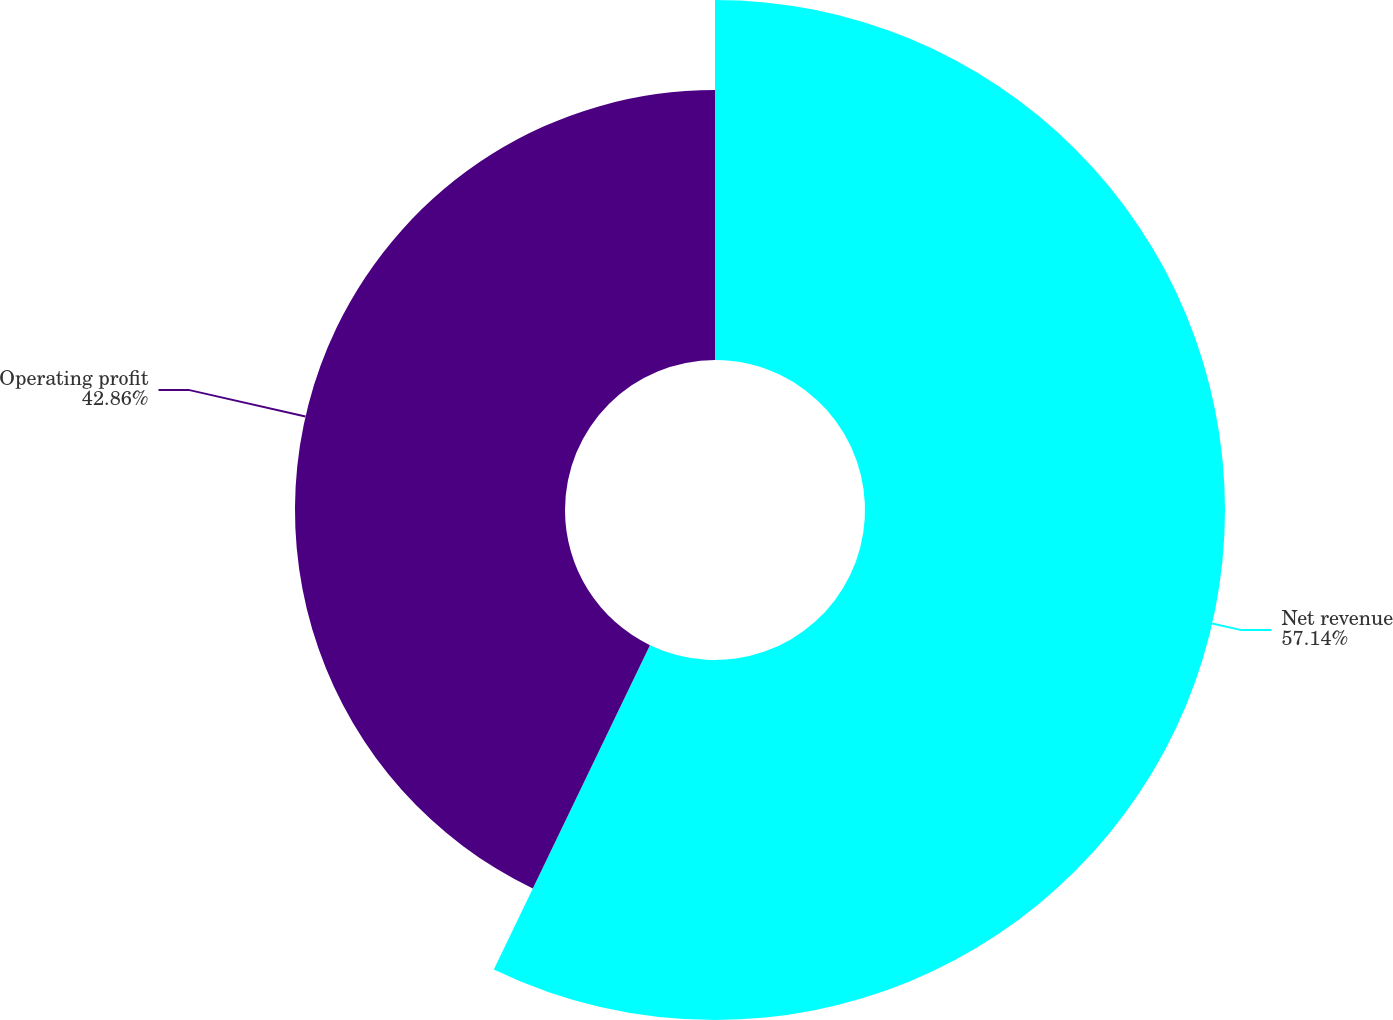<chart> <loc_0><loc_0><loc_500><loc_500><pie_chart><fcel>Net revenue<fcel>Operating profit<nl><fcel>57.14%<fcel>42.86%<nl></chart> 